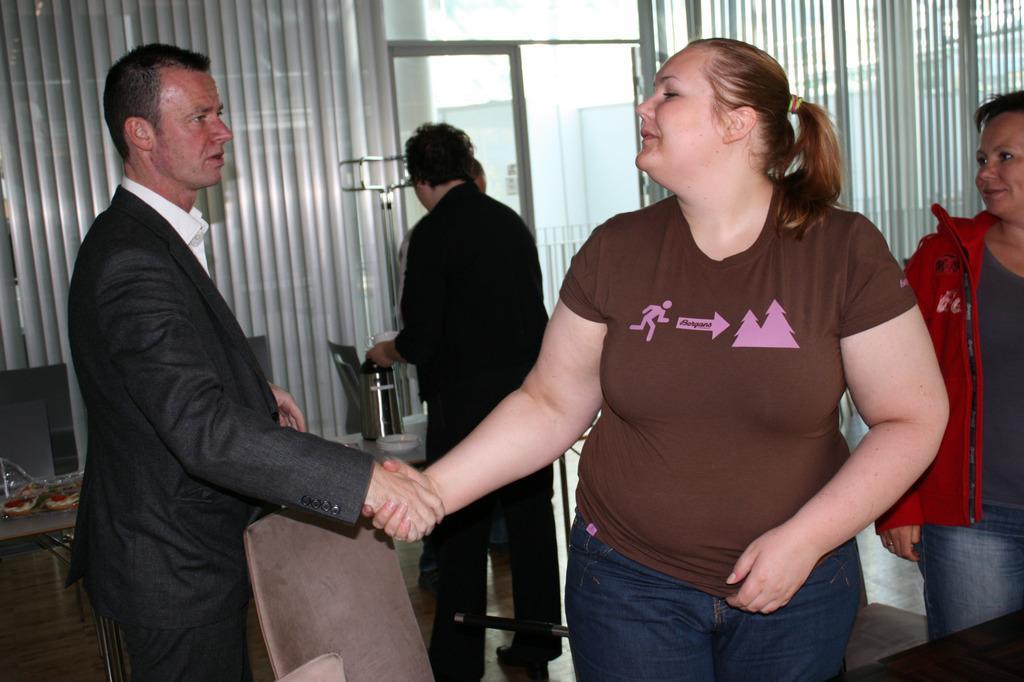Can you describe this image briefly? This image consists of some persons. In the front two persons, who are hand shaking. There are window blinds in the middle. 